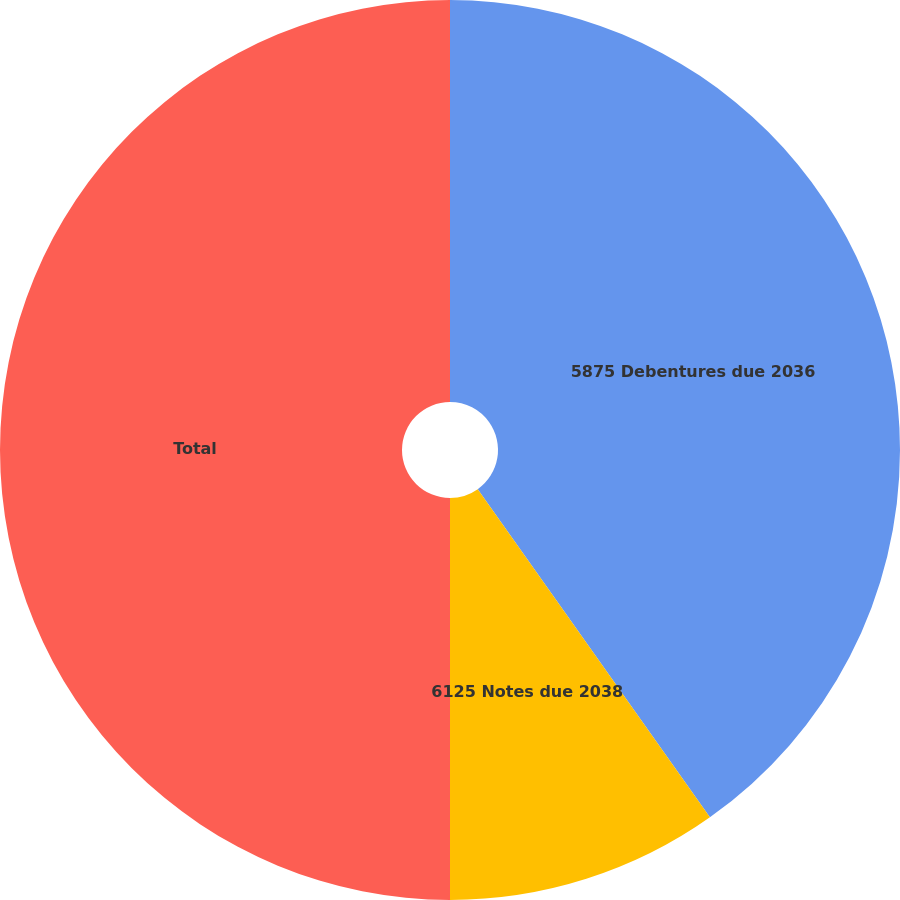<chart> <loc_0><loc_0><loc_500><loc_500><pie_chart><fcel>5875 Debentures due 2036<fcel>6125 Notes due 2038<fcel>Total<nl><fcel>40.2%<fcel>9.8%<fcel>50.0%<nl></chart> 